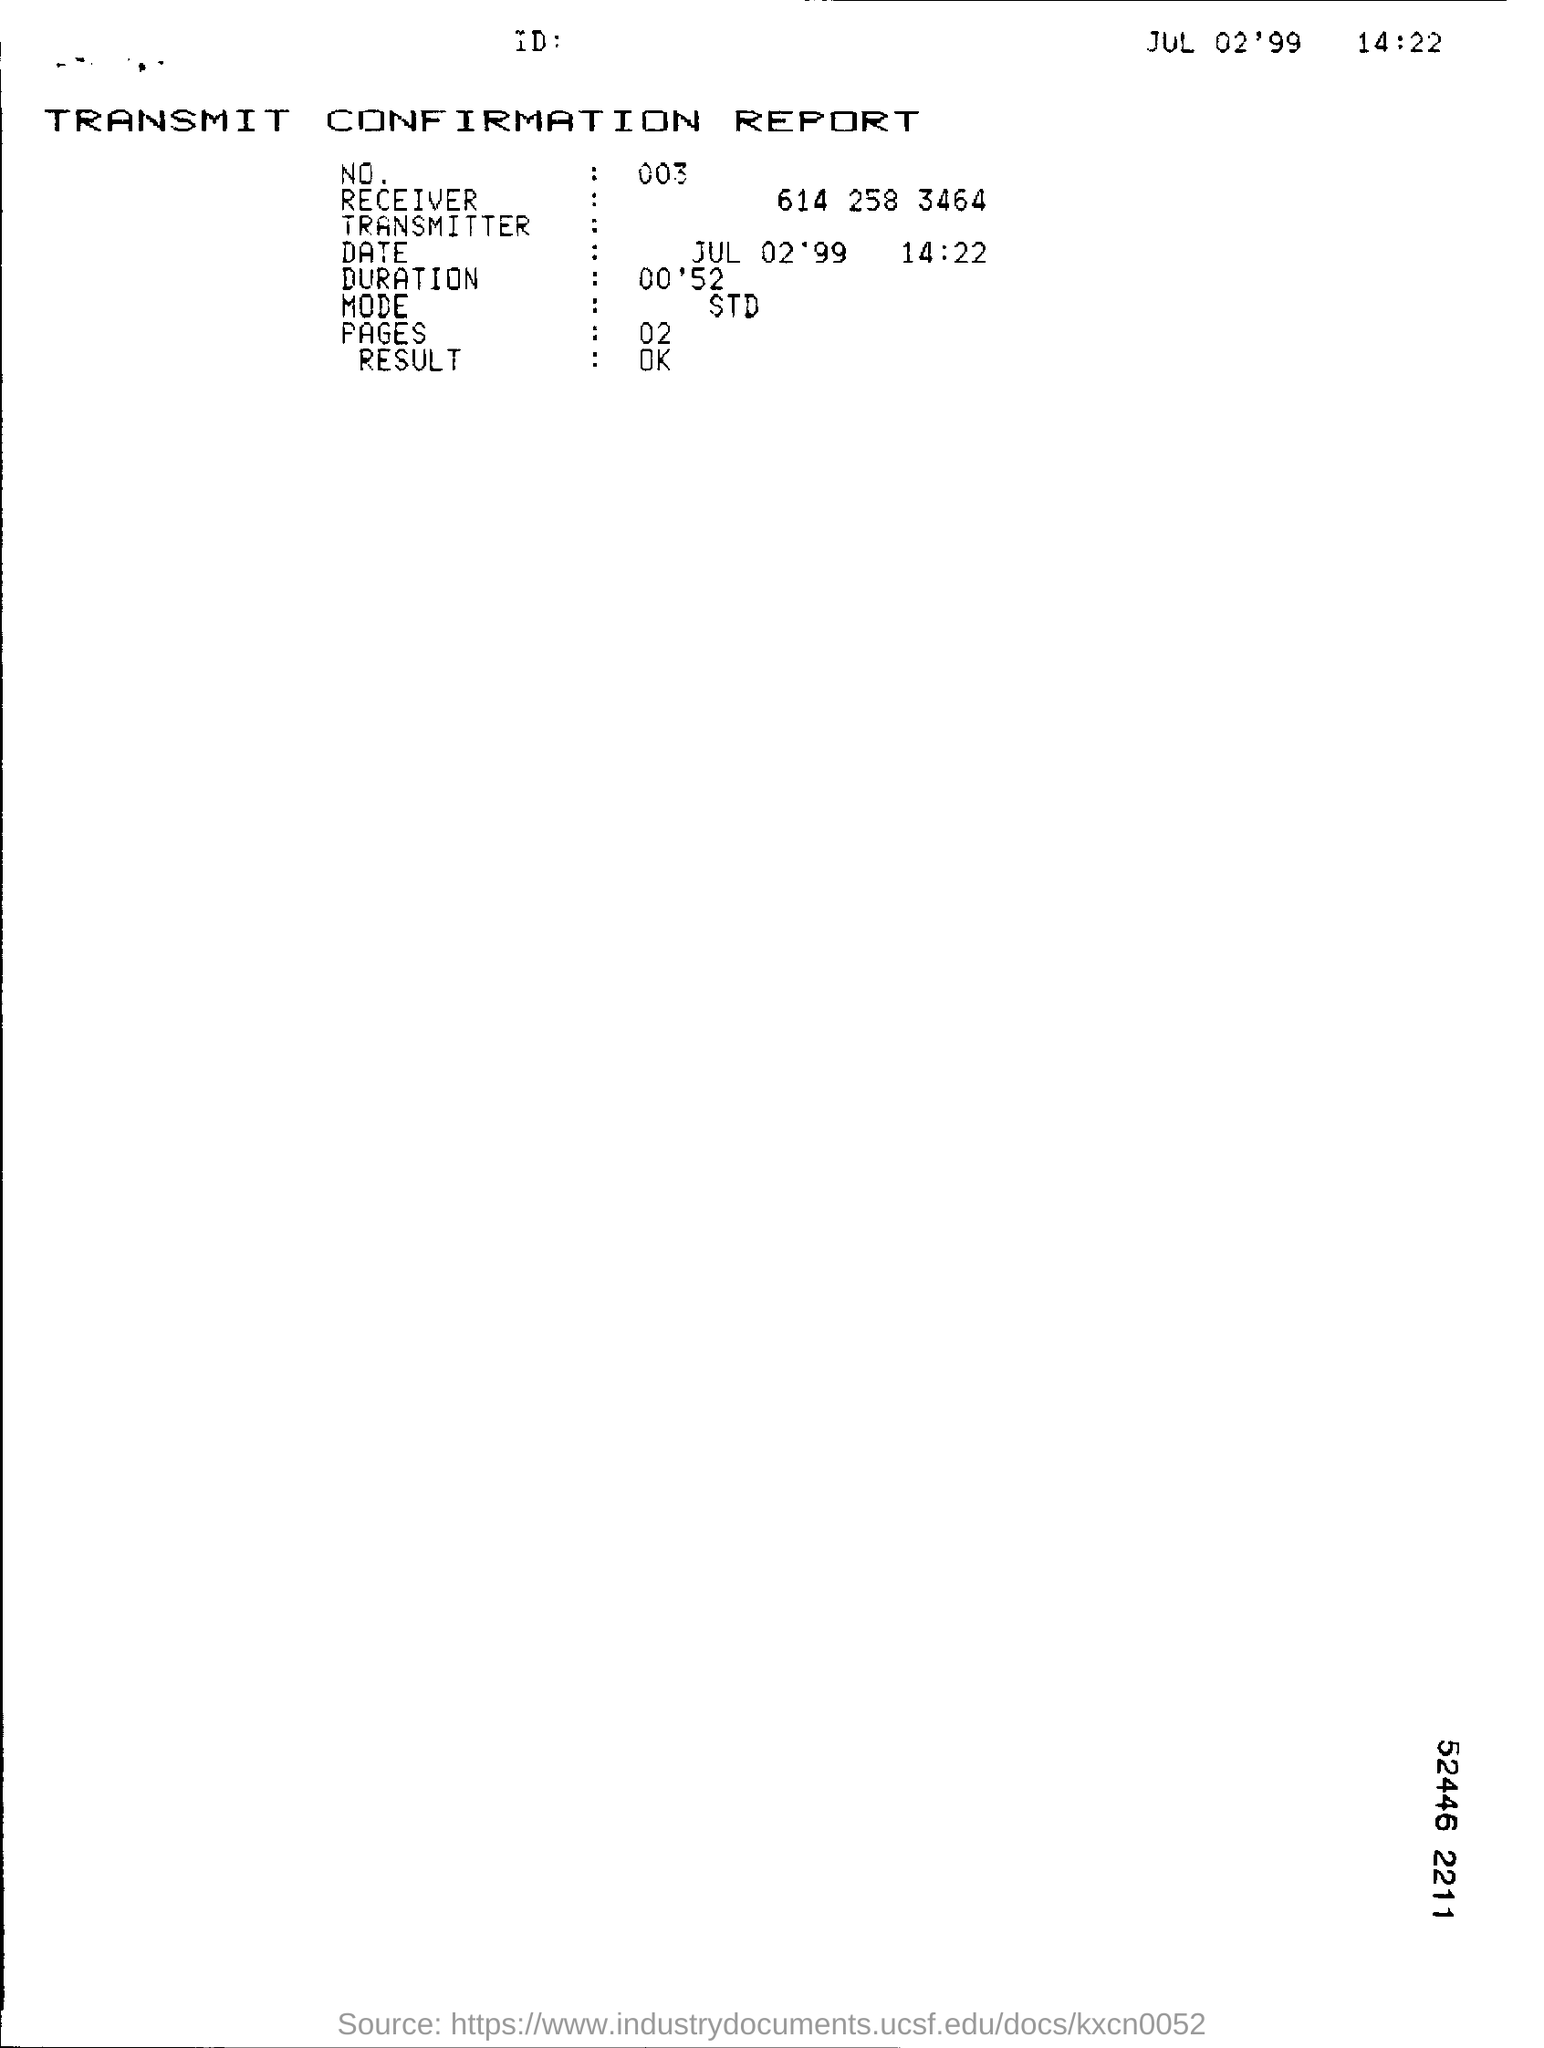What is the 'mode' of transmission?
Keep it short and to the point. STD. 